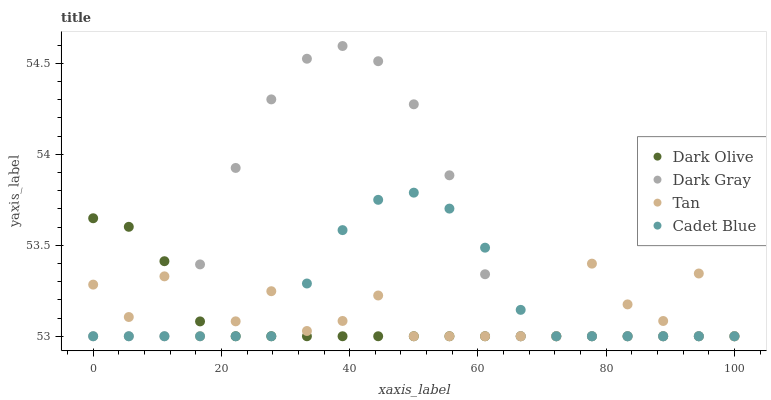Does Dark Olive have the minimum area under the curve?
Answer yes or no. Yes. Does Dark Gray have the maximum area under the curve?
Answer yes or no. Yes. Does Tan have the minimum area under the curve?
Answer yes or no. No. Does Tan have the maximum area under the curve?
Answer yes or no. No. Is Dark Olive the smoothest?
Answer yes or no. Yes. Is Tan the roughest?
Answer yes or no. Yes. Is Tan the smoothest?
Answer yes or no. No. Is Dark Olive the roughest?
Answer yes or no. No. Does Dark Gray have the lowest value?
Answer yes or no. Yes. Does Dark Gray have the highest value?
Answer yes or no. Yes. Does Dark Olive have the highest value?
Answer yes or no. No. Does Dark Olive intersect Tan?
Answer yes or no. Yes. Is Dark Olive less than Tan?
Answer yes or no. No. Is Dark Olive greater than Tan?
Answer yes or no. No. 